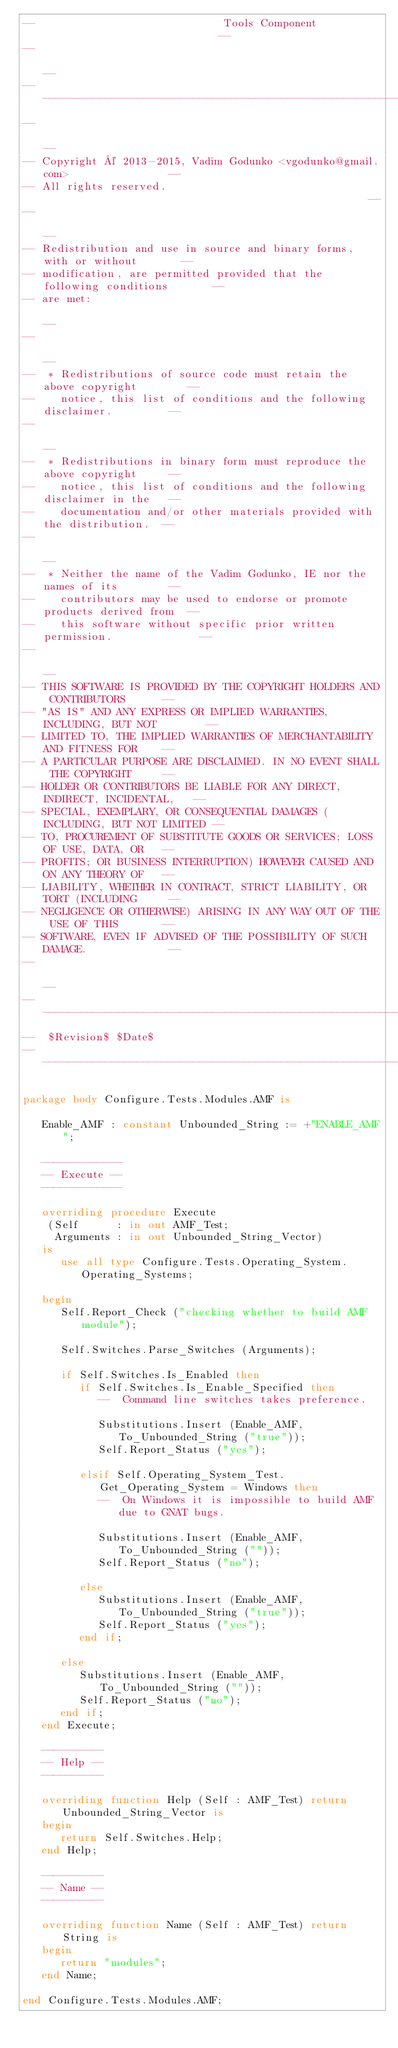<code> <loc_0><loc_0><loc_500><loc_500><_Ada_>--                              Tools Component                             --
--                                                                          --
------------------------------------------------------------------------------
--                                                                          --
-- Copyright © 2013-2015, Vadim Godunko <vgodunko@gmail.com>                --
-- All rights reserved.                                                     --
--                                                                          --
-- Redistribution and use in source and binary forms, with or without       --
-- modification, are permitted provided that the following conditions       --
-- are met:                                                                 --
--                                                                          --
--  * Redistributions of source code must retain the above copyright        --
--    notice, this list of conditions and the following disclaimer.         --
--                                                                          --
--  * Redistributions in binary form must reproduce the above copyright     --
--    notice, this list of conditions and the following disclaimer in the   --
--    documentation and/or other materials provided with the distribution.  --
--                                                                          --
--  * Neither the name of the Vadim Godunko, IE nor the names of its        --
--    contributors may be used to endorse or promote products derived from  --
--    this software without specific prior written permission.              --
--                                                                          --
-- THIS SOFTWARE IS PROVIDED BY THE COPYRIGHT HOLDERS AND CONTRIBUTORS      --
-- "AS IS" AND ANY EXPRESS OR IMPLIED WARRANTIES, INCLUDING, BUT NOT        --
-- LIMITED TO, THE IMPLIED WARRANTIES OF MERCHANTABILITY AND FITNESS FOR    --
-- A PARTICULAR PURPOSE ARE DISCLAIMED. IN NO EVENT SHALL THE COPYRIGHT     --
-- HOLDER OR CONTRIBUTORS BE LIABLE FOR ANY DIRECT, INDIRECT, INCIDENTAL,   --
-- SPECIAL, EXEMPLARY, OR CONSEQUENTIAL DAMAGES (INCLUDING, BUT NOT LIMITED --
-- TO, PROCUREMENT OF SUBSTITUTE GOODS OR SERVICES; LOSS OF USE, DATA, OR   --
-- PROFITS; OR BUSINESS INTERRUPTION) HOWEVER CAUSED AND ON ANY THEORY OF   --
-- LIABILITY, WHETHER IN CONTRACT, STRICT LIABILITY, OR TORT (INCLUDING     --
-- NEGLIGENCE OR OTHERWISE) ARISING IN ANY WAY OUT OF THE USE OF THIS       --
-- SOFTWARE, EVEN IF ADVISED OF THE POSSIBILITY OF SUCH DAMAGE.             --
--                                                                          --
------------------------------------------------------------------------------
--  $Revision$ $Date$
------------------------------------------------------------------------------

package body Configure.Tests.Modules.AMF is

   Enable_AMF : constant Unbounded_String := +"ENABLE_AMF";

   -------------
   -- Execute --
   -------------

   overriding procedure Execute
    (Self      : in out AMF_Test;
     Arguments : in out Unbounded_String_Vector)
   is
      use all type Configure.Tests.Operating_System.Operating_Systems;

   begin
      Self.Report_Check ("checking whether to build AMF module");

      Self.Switches.Parse_Switches (Arguments);

      if Self.Switches.Is_Enabled then
         if Self.Switches.Is_Enable_Specified then
            --  Command line switches takes preference.

            Substitutions.Insert (Enable_AMF, To_Unbounded_String ("true"));
            Self.Report_Status ("yes");

         elsif Self.Operating_System_Test.Get_Operating_System = Windows then
            --  On Windows it is impossible to build AMF due to GNAT bugs.

            Substitutions.Insert (Enable_AMF, To_Unbounded_String (""));
            Self.Report_Status ("no");

         else
            Substitutions.Insert (Enable_AMF, To_Unbounded_String ("true"));
            Self.Report_Status ("yes");
         end if;

      else
         Substitutions.Insert (Enable_AMF, To_Unbounded_String (""));
         Self.Report_Status ("no");
      end if;
   end Execute;

   ----------
   -- Help --
   ----------

   overriding function Help (Self : AMF_Test) return Unbounded_String_Vector is
   begin
      return Self.Switches.Help;
   end Help;

   ----------
   -- Name --
   ----------

   overriding function Name (Self : AMF_Test) return String is
   begin
      return "modules";
   end Name;

end Configure.Tests.Modules.AMF;
</code> 